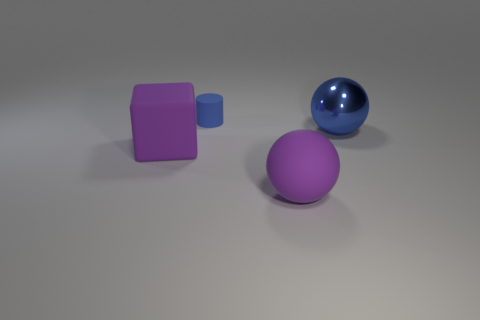Is there any other thing that has the same material as the blue sphere?
Your answer should be very brief. No. Are there any other things that are the same size as the blue cylinder?
Ensure brevity in your answer.  No. Is there any other thing that is the same shape as the small thing?
Make the answer very short. No. Do the metallic ball and the matte cylinder have the same color?
Offer a very short reply. Yes. There is a ball that is left of the large metallic thing; how big is it?
Keep it short and to the point. Large. What number of large purple things have the same shape as the blue metal thing?
Provide a succinct answer. 1. There is a small object that is the same material as the cube; what shape is it?
Make the answer very short. Cylinder. What number of blue objects are either tiny rubber objects or big shiny spheres?
Provide a short and direct response. 2. There is a metal ball; are there any large balls to the left of it?
Offer a very short reply. Yes. There is a thing that is on the right side of the purple matte sphere; does it have the same shape as the rubber thing to the right of the blue matte cylinder?
Keep it short and to the point. Yes. 